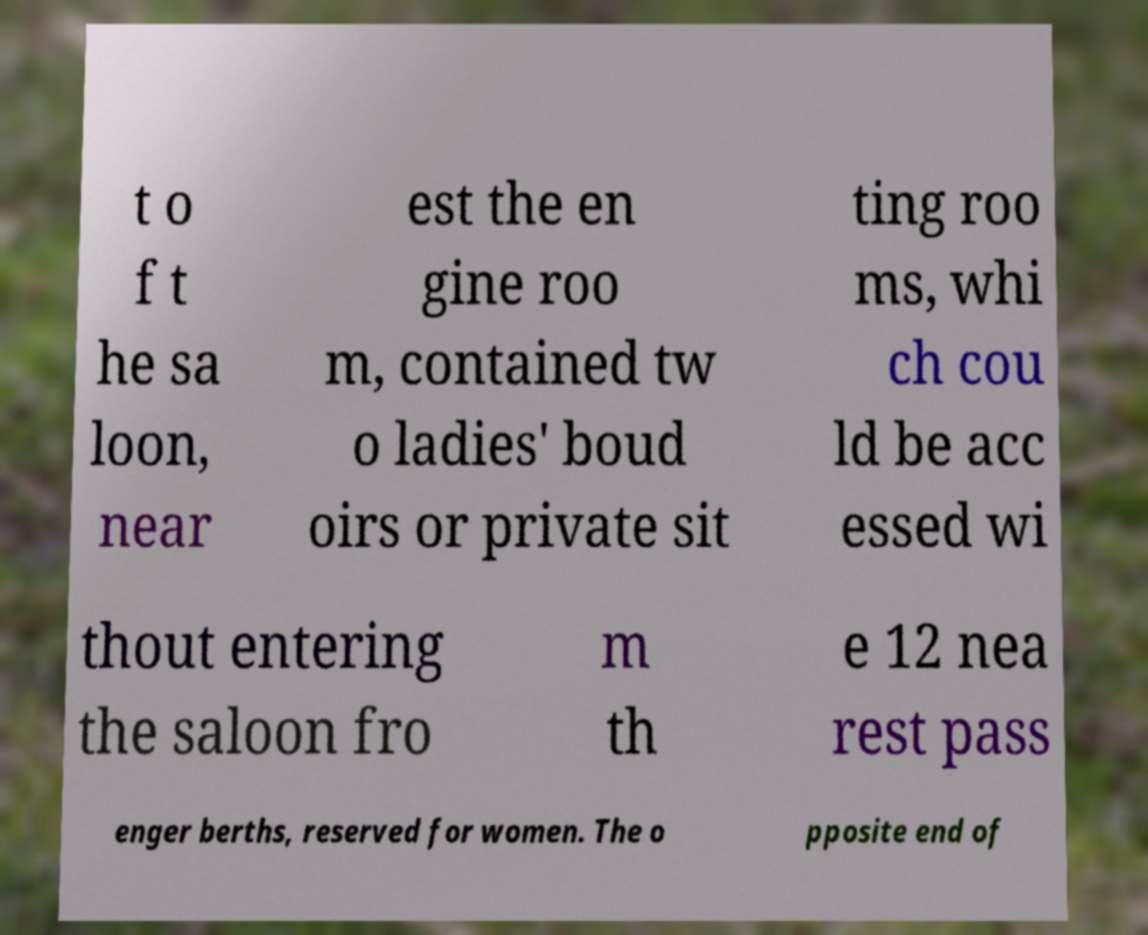What messages or text are displayed in this image? I need them in a readable, typed format. t o f t he sa loon, near est the en gine roo m, contained tw o ladies' boud oirs or private sit ting roo ms, whi ch cou ld be acc essed wi thout entering the saloon fro m th e 12 nea rest pass enger berths, reserved for women. The o pposite end of 